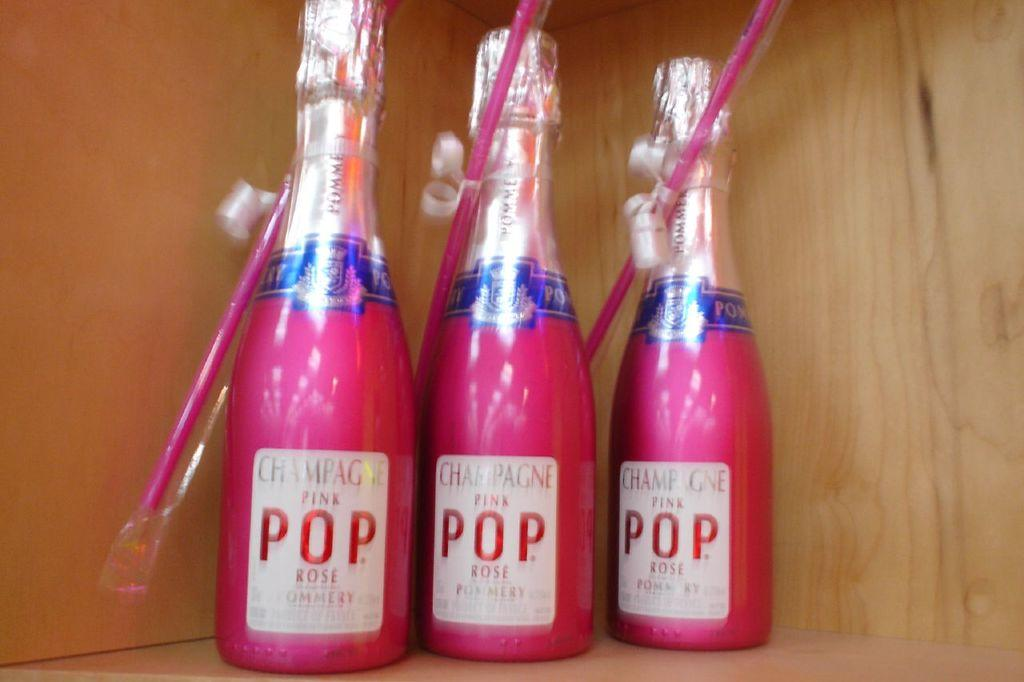<image>
Share a concise interpretation of the image provided. Three bottles of pink pop Champagne sit together. 